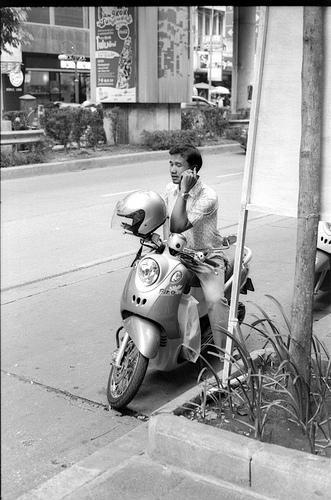How many people are there?
Give a very brief answer. 1. 